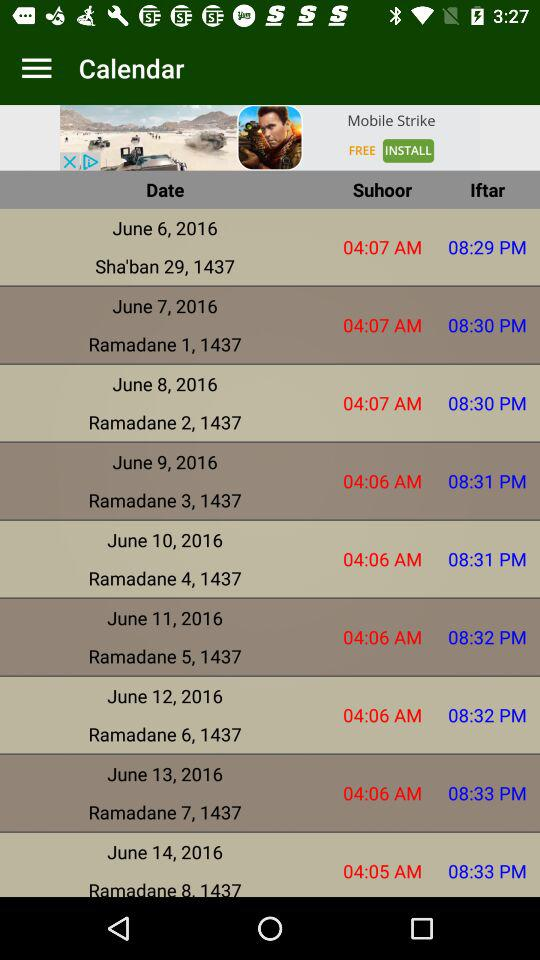What is the "Suhoor" time for "Sha'ban 29, 1437"? The time is 04:07 AM. 